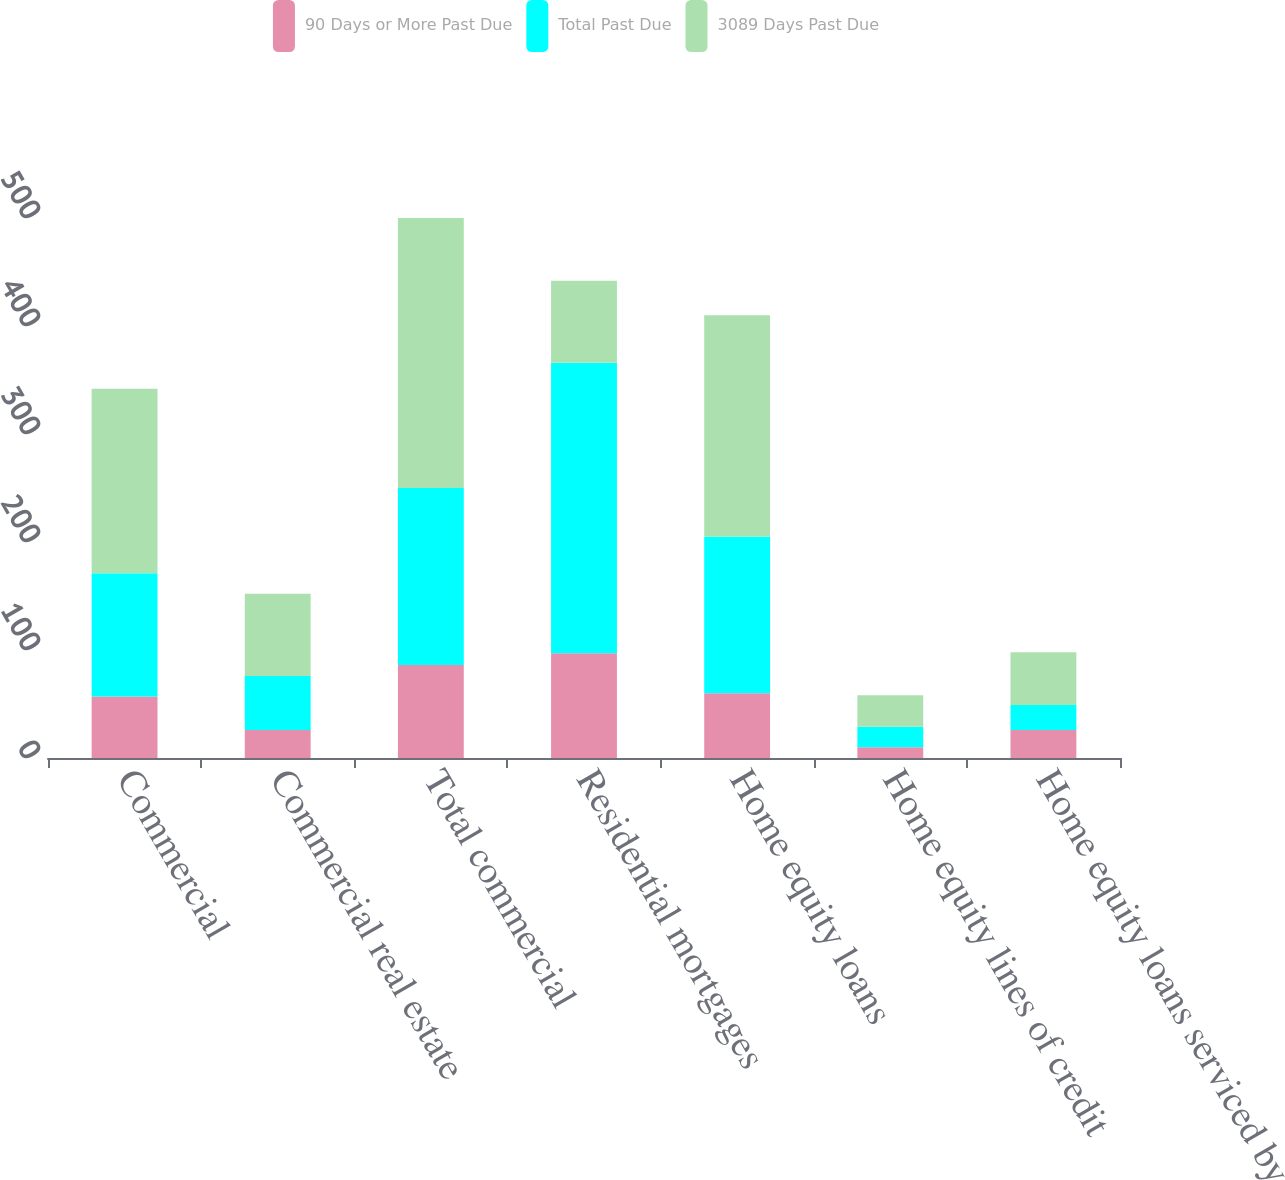<chart> <loc_0><loc_0><loc_500><loc_500><stacked_bar_chart><ecel><fcel>Commercial<fcel>Commercial real estate<fcel>Total commercial<fcel>Residential mortgages<fcel>Home equity loans<fcel>Home equity lines of credit<fcel>Home equity loans serviced by<nl><fcel>90 Days or More Past Due<fcel>57<fcel>26<fcel>86<fcel>97<fcel>60<fcel>10<fcel>26<nl><fcel>Total Past Due<fcel>114<fcel>50<fcel>164<fcel>269<fcel>145<fcel>19<fcel>23<nl><fcel>3089 Days Past Due<fcel>171<fcel>76<fcel>250<fcel>76<fcel>205<fcel>29<fcel>49<nl></chart> 